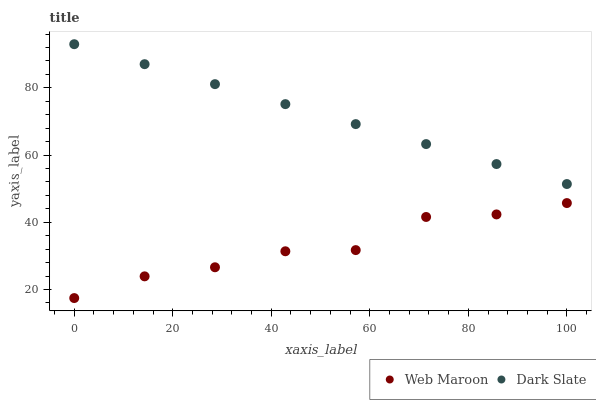Does Web Maroon have the minimum area under the curve?
Answer yes or no. Yes. Does Dark Slate have the maximum area under the curve?
Answer yes or no. Yes. Does Web Maroon have the maximum area under the curve?
Answer yes or no. No. Is Dark Slate the smoothest?
Answer yes or no. Yes. Is Web Maroon the roughest?
Answer yes or no. Yes. Is Web Maroon the smoothest?
Answer yes or no. No. Does Web Maroon have the lowest value?
Answer yes or no. Yes. Does Dark Slate have the highest value?
Answer yes or no. Yes. Does Web Maroon have the highest value?
Answer yes or no. No. Is Web Maroon less than Dark Slate?
Answer yes or no. Yes. Is Dark Slate greater than Web Maroon?
Answer yes or no. Yes. Does Web Maroon intersect Dark Slate?
Answer yes or no. No. 